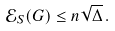Convert formula to latex. <formula><loc_0><loc_0><loc_500><loc_500>\mathcal { E } _ { S } ( G ) \leq n \sqrt { \Delta } \, .</formula> 